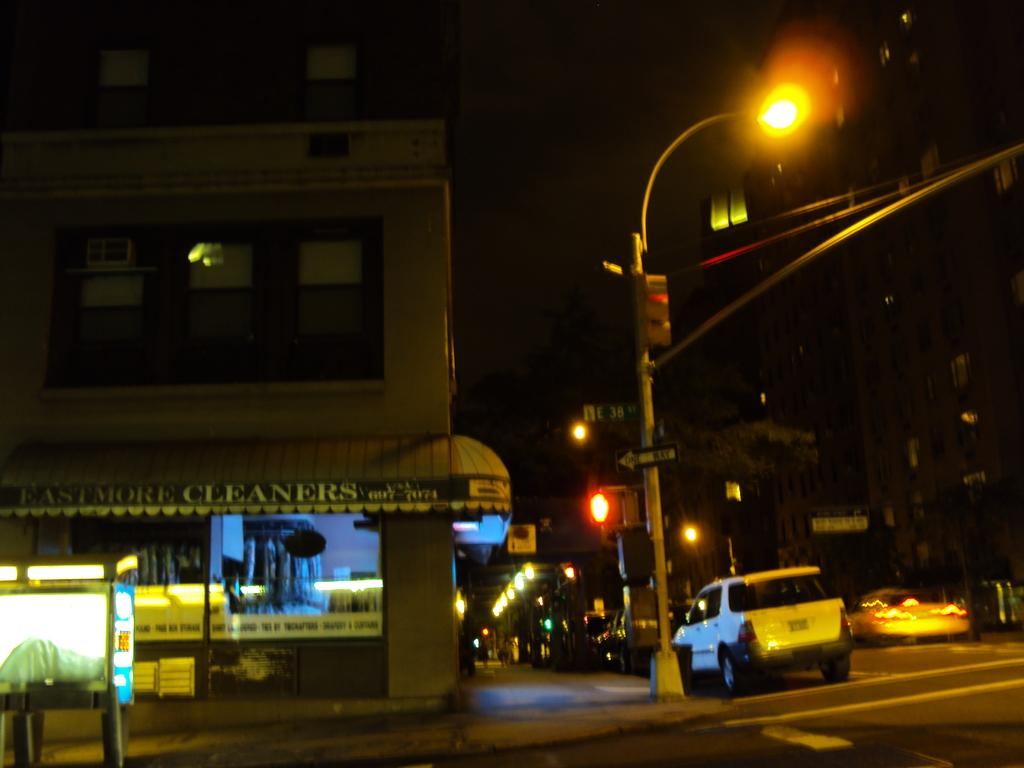<image>
Offer a succinct explanation of the picture presented. On a dark corner Eastmore Cleaners store sign is light up 